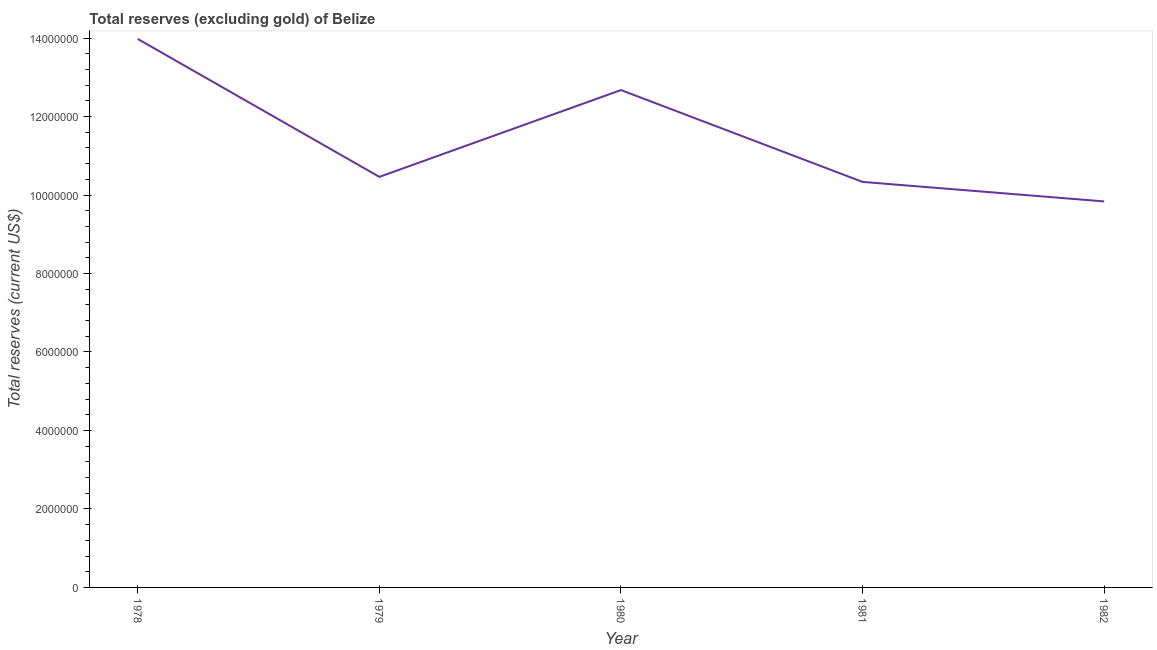What is the total reserves (excluding gold) in 1979?
Give a very brief answer. 1.05e+07. Across all years, what is the maximum total reserves (excluding gold)?
Ensure brevity in your answer.  1.40e+07. Across all years, what is the minimum total reserves (excluding gold)?
Offer a terse response. 9.84e+06. In which year was the total reserves (excluding gold) maximum?
Offer a very short reply. 1978. What is the sum of the total reserves (excluding gold)?
Make the answer very short. 5.73e+07. What is the difference between the total reserves (excluding gold) in 1978 and 1979?
Offer a very short reply. 3.52e+06. What is the average total reserves (excluding gold) per year?
Provide a succinct answer. 1.15e+07. What is the median total reserves (excluding gold)?
Give a very brief answer. 1.05e+07. In how many years, is the total reserves (excluding gold) greater than 11200000 US$?
Your answer should be very brief. 2. What is the ratio of the total reserves (excluding gold) in 1980 to that in 1981?
Keep it short and to the point. 1.23. What is the difference between the highest and the second highest total reserves (excluding gold)?
Ensure brevity in your answer.  1.30e+06. Is the sum of the total reserves (excluding gold) in 1980 and 1981 greater than the maximum total reserves (excluding gold) across all years?
Keep it short and to the point. Yes. What is the difference between the highest and the lowest total reserves (excluding gold)?
Give a very brief answer. 4.14e+06. Does the total reserves (excluding gold) monotonically increase over the years?
Ensure brevity in your answer.  No. How many years are there in the graph?
Offer a very short reply. 5. What is the difference between two consecutive major ticks on the Y-axis?
Offer a very short reply. 2.00e+06. Does the graph contain any zero values?
Provide a succinct answer. No. What is the title of the graph?
Offer a terse response. Total reserves (excluding gold) of Belize. What is the label or title of the X-axis?
Ensure brevity in your answer.  Year. What is the label or title of the Y-axis?
Give a very brief answer. Total reserves (current US$). What is the Total reserves (current US$) of 1978?
Your answer should be very brief. 1.40e+07. What is the Total reserves (current US$) of 1979?
Keep it short and to the point. 1.05e+07. What is the Total reserves (current US$) in 1980?
Ensure brevity in your answer.  1.27e+07. What is the Total reserves (current US$) in 1981?
Your answer should be very brief. 1.03e+07. What is the Total reserves (current US$) in 1982?
Your answer should be compact. 9.84e+06. What is the difference between the Total reserves (current US$) in 1978 and 1979?
Ensure brevity in your answer.  3.52e+06. What is the difference between the Total reserves (current US$) in 1978 and 1980?
Your answer should be very brief. 1.30e+06. What is the difference between the Total reserves (current US$) in 1978 and 1981?
Your response must be concise. 3.64e+06. What is the difference between the Total reserves (current US$) in 1978 and 1982?
Provide a short and direct response. 4.14e+06. What is the difference between the Total reserves (current US$) in 1979 and 1980?
Offer a very short reply. -2.21e+06. What is the difference between the Total reserves (current US$) in 1979 and 1981?
Offer a very short reply. 1.28e+05. What is the difference between the Total reserves (current US$) in 1979 and 1982?
Give a very brief answer. 6.26e+05. What is the difference between the Total reserves (current US$) in 1980 and 1981?
Give a very brief answer. 2.34e+06. What is the difference between the Total reserves (current US$) in 1980 and 1982?
Provide a short and direct response. 2.84e+06. What is the difference between the Total reserves (current US$) in 1981 and 1982?
Your answer should be compact. 4.97e+05. What is the ratio of the Total reserves (current US$) in 1978 to that in 1979?
Provide a short and direct response. 1.34. What is the ratio of the Total reserves (current US$) in 1978 to that in 1980?
Offer a terse response. 1.1. What is the ratio of the Total reserves (current US$) in 1978 to that in 1981?
Provide a short and direct response. 1.35. What is the ratio of the Total reserves (current US$) in 1978 to that in 1982?
Ensure brevity in your answer.  1.42. What is the ratio of the Total reserves (current US$) in 1979 to that in 1980?
Keep it short and to the point. 0.82. What is the ratio of the Total reserves (current US$) in 1979 to that in 1982?
Provide a succinct answer. 1.06. What is the ratio of the Total reserves (current US$) in 1980 to that in 1981?
Your answer should be compact. 1.23. What is the ratio of the Total reserves (current US$) in 1980 to that in 1982?
Provide a succinct answer. 1.29. What is the ratio of the Total reserves (current US$) in 1981 to that in 1982?
Your answer should be compact. 1.05. 